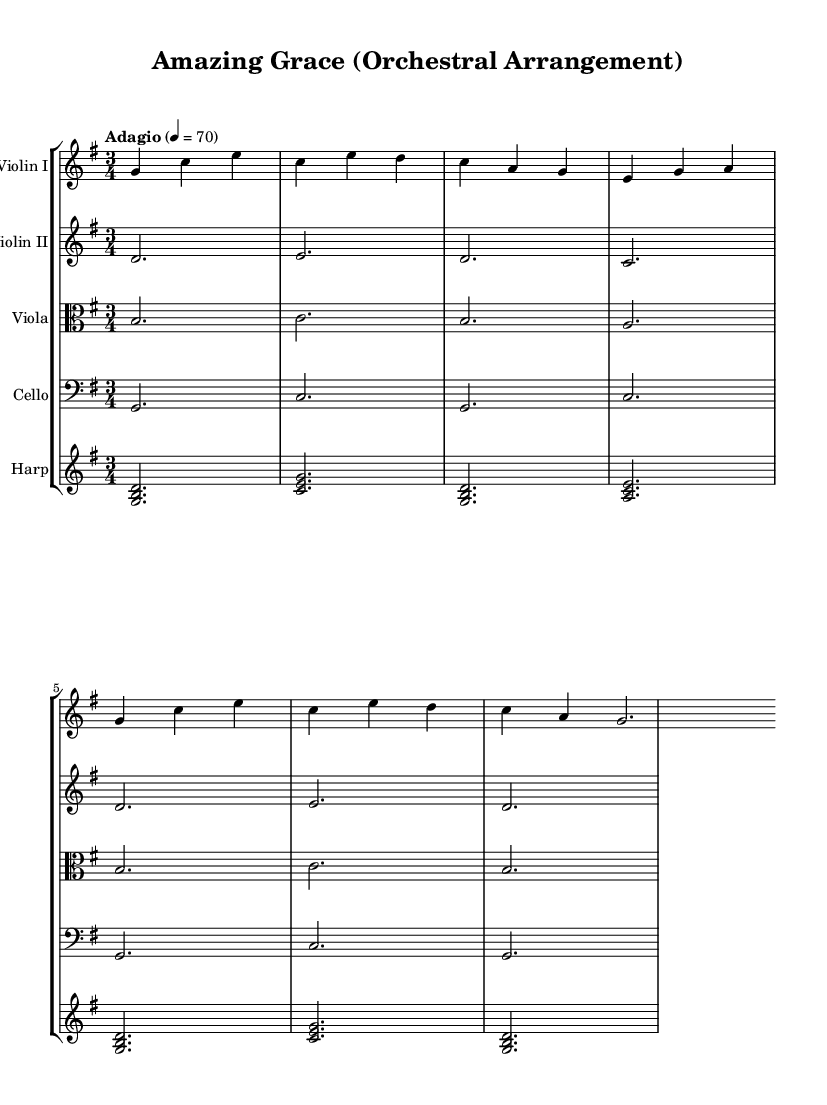What is the key signature of this music? The key signature shows one sharp on the staff, indicating that the piece is in the key of G major. The presence of an F sharp suggests this key.
Answer: G major What is the time signature of this music? The time signature is indicated by the numbers seen at the beginning of the score. It shows three beats per measure, thus it is in 3/4 time.
Answer: 3/4 What is the tempo marking of this music? The tempo marking provides information about the pace of the piece. The score states "Adagio" with a metronome marking of 70, indicating a slow tempo.
Answer: Adagio Which instruments are included in this orchestral arrangement? By looking at the score, we can identify the instruments listed in the staff group. The instruments are Violin I, Violin II, Viola, Cello, and Harp.
Answer: Violin I, Violin II, Viola, Cello, Harp How many measures are present in the Violin I part? To determine the number of measures, count each segment separated by vertical lines in the Violin I staff. There are 6 measures visible.
Answer: 6 What is the highest pitch instrument in this arrangement? Examine the range of each instrument. The Violin I part, generally located at the top of the score, typically plays higher pitches compared to the others. Thus, it is the highest.
Answer: Violin I Which chord does the harp play at the beginning of the piece? Inspect the first measure of the harp part, where it shows a G major chord consisting of the notes G, B, and D. This identifies the chord played initially.
Answer: G major 